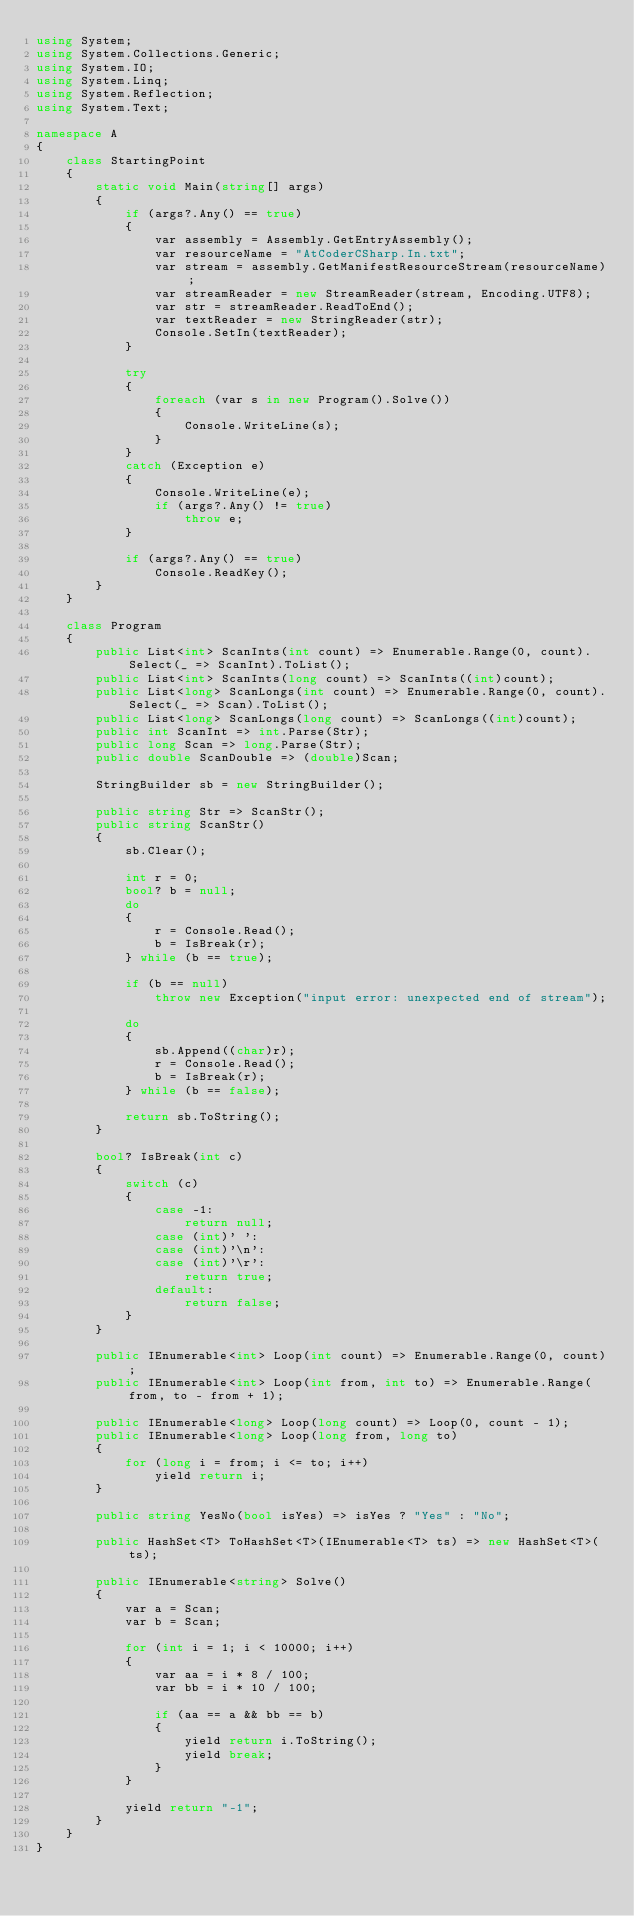<code> <loc_0><loc_0><loc_500><loc_500><_C#_>using System;
using System.Collections.Generic;
using System.IO;
using System.Linq;
using System.Reflection;
using System.Text;

namespace A
{
    class StartingPoint
    {
        static void Main(string[] args)
        {
            if (args?.Any() == true)
            {
                var assembly = Assembly.GetEntryAssembly();
                var resourceName = "AtCoderCSharp.In.txt";
                var stream = assembly.GetManifestResourceStream(resourceName);
                var streamReader = new StreamReader(stream, Encoding.UTF8);
                var str = streamReader.ReadToEnd();
                var textReader = new StringReader(str);
                Console.SetIn(textReader);
            }

            try
            {
                foreach (var s in new Program().Solve())
                {
                    Console.WriteLine(s);
                }
            }
            catch (Exception e)
            {
                Console.WriteLine(e);
                if (args?.Any() != true)
                    throw e;
            }

            if (args?.Any() == true)
                Console.ReadKey();
        }
    }

    class Program
    {
        public List<int> ScanInts(int count) => Enumerable.Range(0, count).Select(_ => ScanInt).ToList();
        public List<int> ScanInts(long count) => ScanInts((int)count);
        public List<long> ScanLongs(int count) => Enumerable.Range(0, count).Select(_ => Scan).ToList();
        public List<long> ScanLongs(long count) => ScanLongs((int)count);
        public int ScanInt => int.Parse(Str);
        public long Scan => long.Parse(Str);
        public double ScanDouble => (double)Scan;

        StringBuilder sb = new StringBuilder();

        public string Str => ScanStr();
        public string ScanStr()
        {
            sb.Clear();

            int r = 0;
            bool? b = null;
            do
            {
                r = Console.Read();
                b = IsBreak(r);
            } while (b == true);

            if (b == null)
                throw new Exception("input error: unexpected end of stream");

            do
            {
                sb.Append((char)r);
                r = Console.Read();
                b = IsBreak(r);
            } while (b == false);

            return sb.ToString();
        }

        bool? IsBreak(int c)
        {
            switch (c)
            {
                case -1:
                    return null;
                case (int)' ':
                case (int)'\n':
                case (int)'\r':
                    return true;
                default:
                    return false;
            }
        }

        public IEnumerable<int> Loop(int count) => Enumerable.Range(0, count);
        public IEnumerable<int> Loop(int from, int to) => Enumerable.Range(from, to - from + 1);

        public IEnumerable<long> Loop(long count) => Loop(0, count - 1);
        public IEnumerable<long> Loop(long from, long to)
        {
            for (long i = from; i <= to; i++)
                yield return i;
        }

        public string YesNo(bool isYes) => isYes ? "Yes" : "No";

        public HashSet<T> ToHashSet<T>(IEnumerable<T> ts) => new HashSet<T>(ts);

        public IEnumerable<string> Solve()
        {
            var a = Scan;
            var b = Scan;

            for (int i = 1; i < 10000; i++)
            {
                var aa = i * 8 / 100;
                var bb = i * 10 / 100;

                if (aa == a && bb == b)
                {
                    yield return i.ToString();
                    yield break;
                }
            }

            yield return "-1";
        }
    }
}</code> 